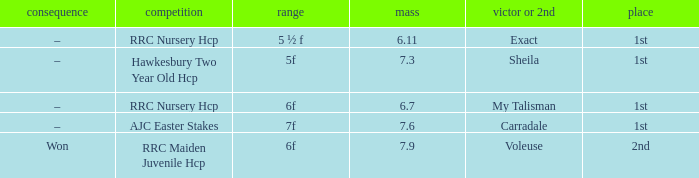What is the weight number when the distance was 5 ½ f? 1.0. 